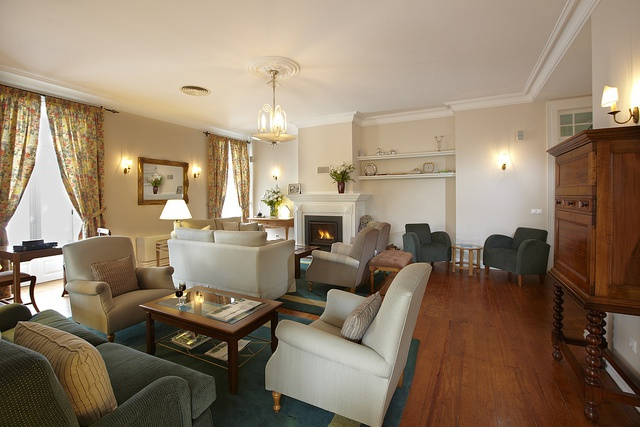Describe the objects in this image and their specific colors. I can see chair in darkgray, gray, and lightgray tones, couch in darkgray, black, gray, and olive tones, couch in darkgray and gray tones, chair in darkgray, gray, and maroon tones, and chair in darkgray, gray, maroon, and black tones in this image. 